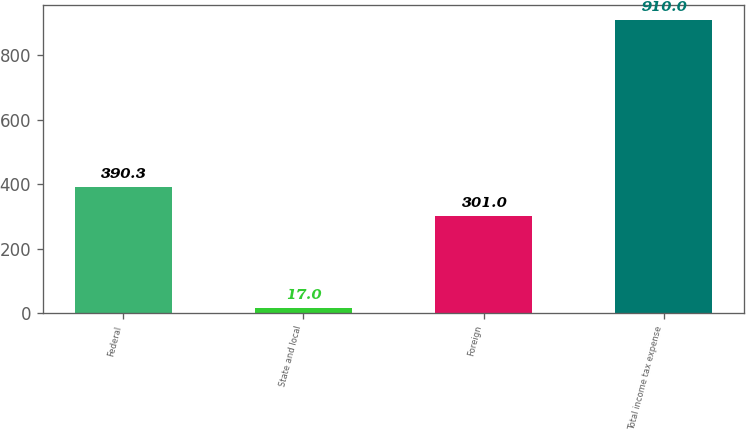Convert chart. <chart><loc_0><loc_0><loc_500><loc_500><bar_chart><fcel>Federal<fcel>State and local<fcel>Foreign<fcel>Total income tax expense<nl><fcel>390.3<fcel>17<fcel>301<fcel>910<nl></chart> 